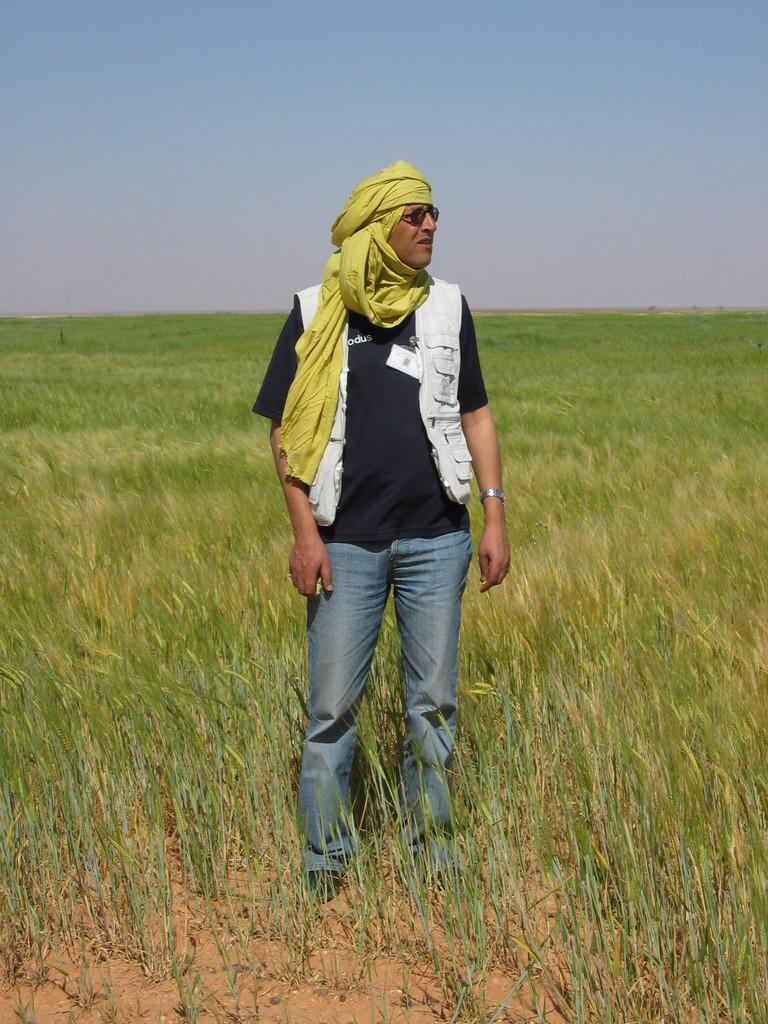What is the main subject of the image? There is a person standing in the image. What type of environment is the person in? There is grass visible in the image, suggesting a natural setting. What color is the heart-shaped lipstick the person is wearing in the image? There is no mention of lipstick, a heart shape, or a specific color in the provided facts, so we cannot answer this question based on the image. 